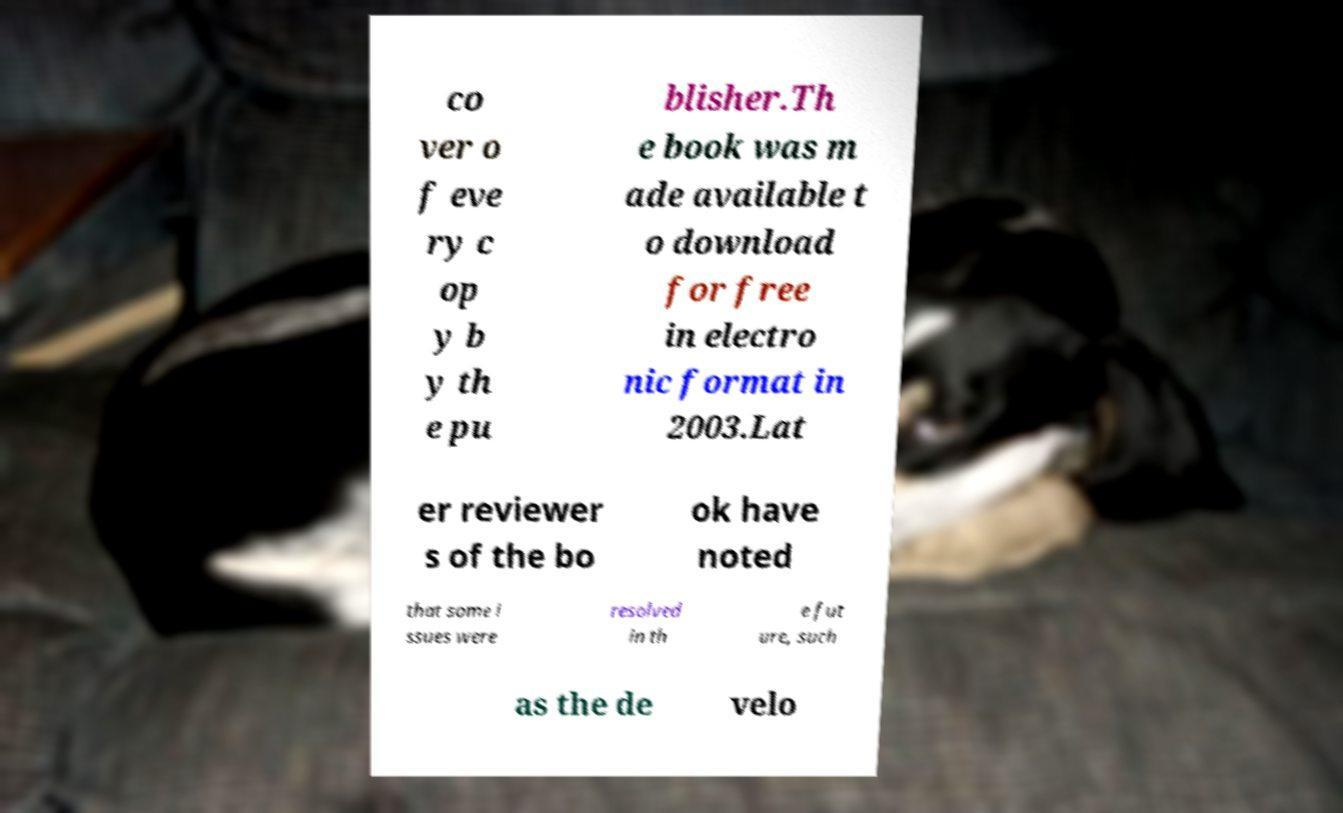There's text embedded in this image that I need extracted. Can you transcribe it verbatim? co ver o f eve ry c op y b y th e pu blisher.Th e book was m ade available t o download for free in electro nic format in 2003.Lat er reviewer s of the bo ok have noted that some i ssues were resolved in th e fut ure, such as the de velo 